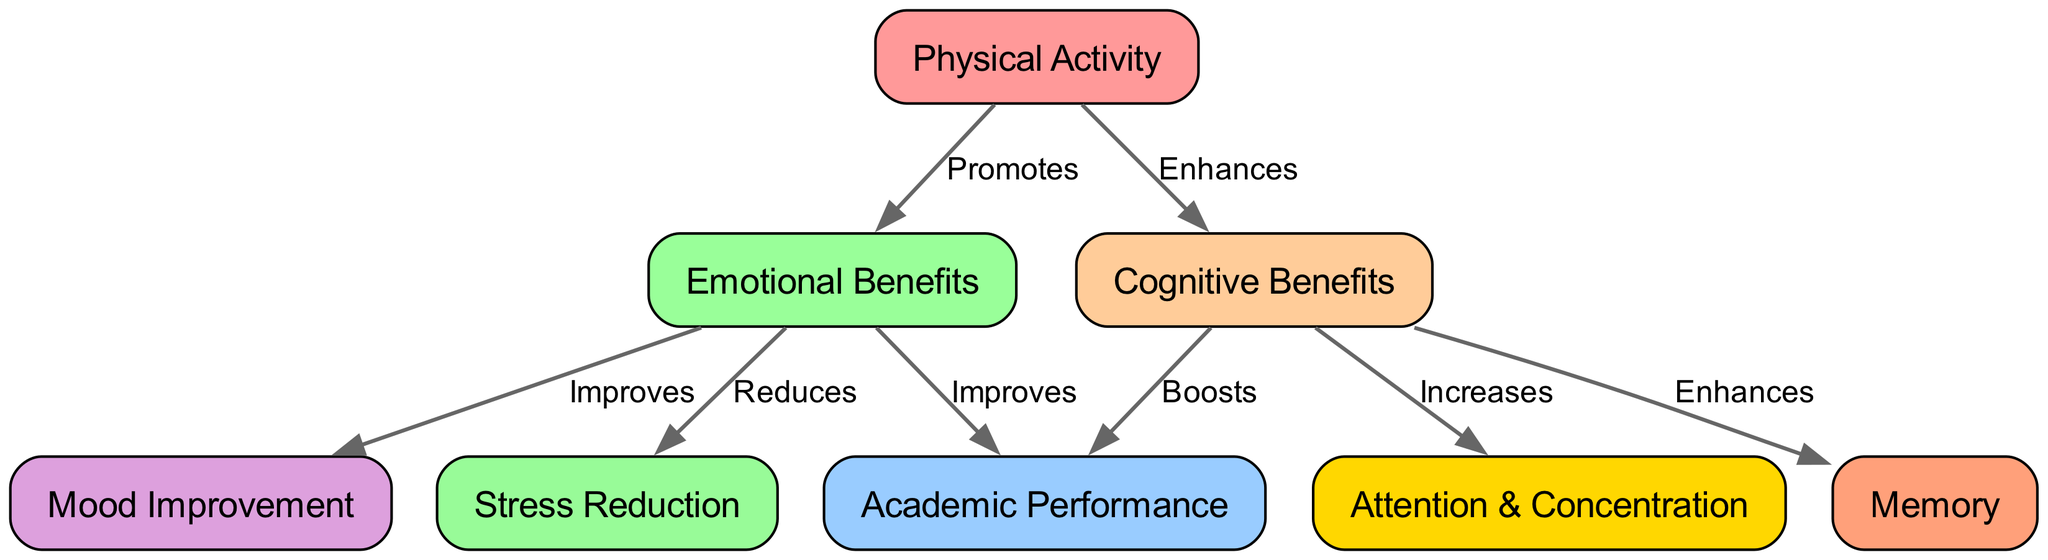What are the main benefits of physical activity? According to the diagram, physical activity enhances cognitive benefits and promotes emotional benefits. So, the main benefits listed are cognitive benefits and emotional benefits.
Answer: Cognitive benefits and emotional benefits How many nodes are in the diagram? The diagram lists a total of 8 nodes (physical activity, academic performance, cognitive benefits, emotional benefits, attention, memory, stress reduction, and mood improvement).
Answer: 8 What does cognitive benefits enhance in relation to academic performance? The diagram shows that cognitive benefits boost academic performance. This indicates that improvements in cognitive abilities, as a result of physical activity, positively impact a student's academic success.
Answer: Boosts What relationship exists between emotional benefits and stress reduction? The diagram indicates that emotional benefits reduce stress. This relationship suggests that positive emotional states resulting from physical activity can lower stress levels.
Answer: Reduces Which outcome results directly from attention and concentration benefits? Attention and concentration are increased due to cognitive benefits, which in turn correlate with academic performance through improved focus during learning activities.
Answer: Increases How does physical activity affect emotional benefits? The diagram states that physical activity promotes emotional benefits, which implies that engaging in physical activities can enhance one's emotional well-being.
Answer: Promotes What is the connection between memory and cognitive benefits? According to the diagram, cognitive benefits enhance memory, indicating that improved cognitive function can lead to better memory retention and recall.
Answer: Enhances In total, how many edges are present in this diagram? The diagram displays 8 directed edges, illustrating the relationships among the nodes (physical activity, cognitive benefits, emotional benefits, academic performance, attention, memory, stress reduction, mood improvement).
Answer: 8 What does emotional benefits improve in relation to academic performance? The diagram shows that emotional benefits improve academic performance, meaning that positive emotional experiences can enhance students' learning outcomes.
Answer: Improves 